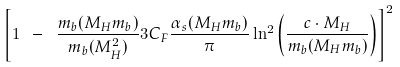<formula> <loc_0><loc_0><loc_500><loc_500>\left [ 1 \ - \ \frac { m _ { b } ( M _ { H } m _ { b } ) } { m _ { b } ( M _ { H } ^ { 2 } ) } 3 C _ { F } \frac { \alpha _ { s } ( M _ { H } m _ { b } ) } { \pi } \ln ^ { 2 } \left ( \frac { c \cdot M _ { H } } { m _ { b } ( M _ { H } m _ { b } ) } \right ) \right ] ^ { 2 }</formula> 